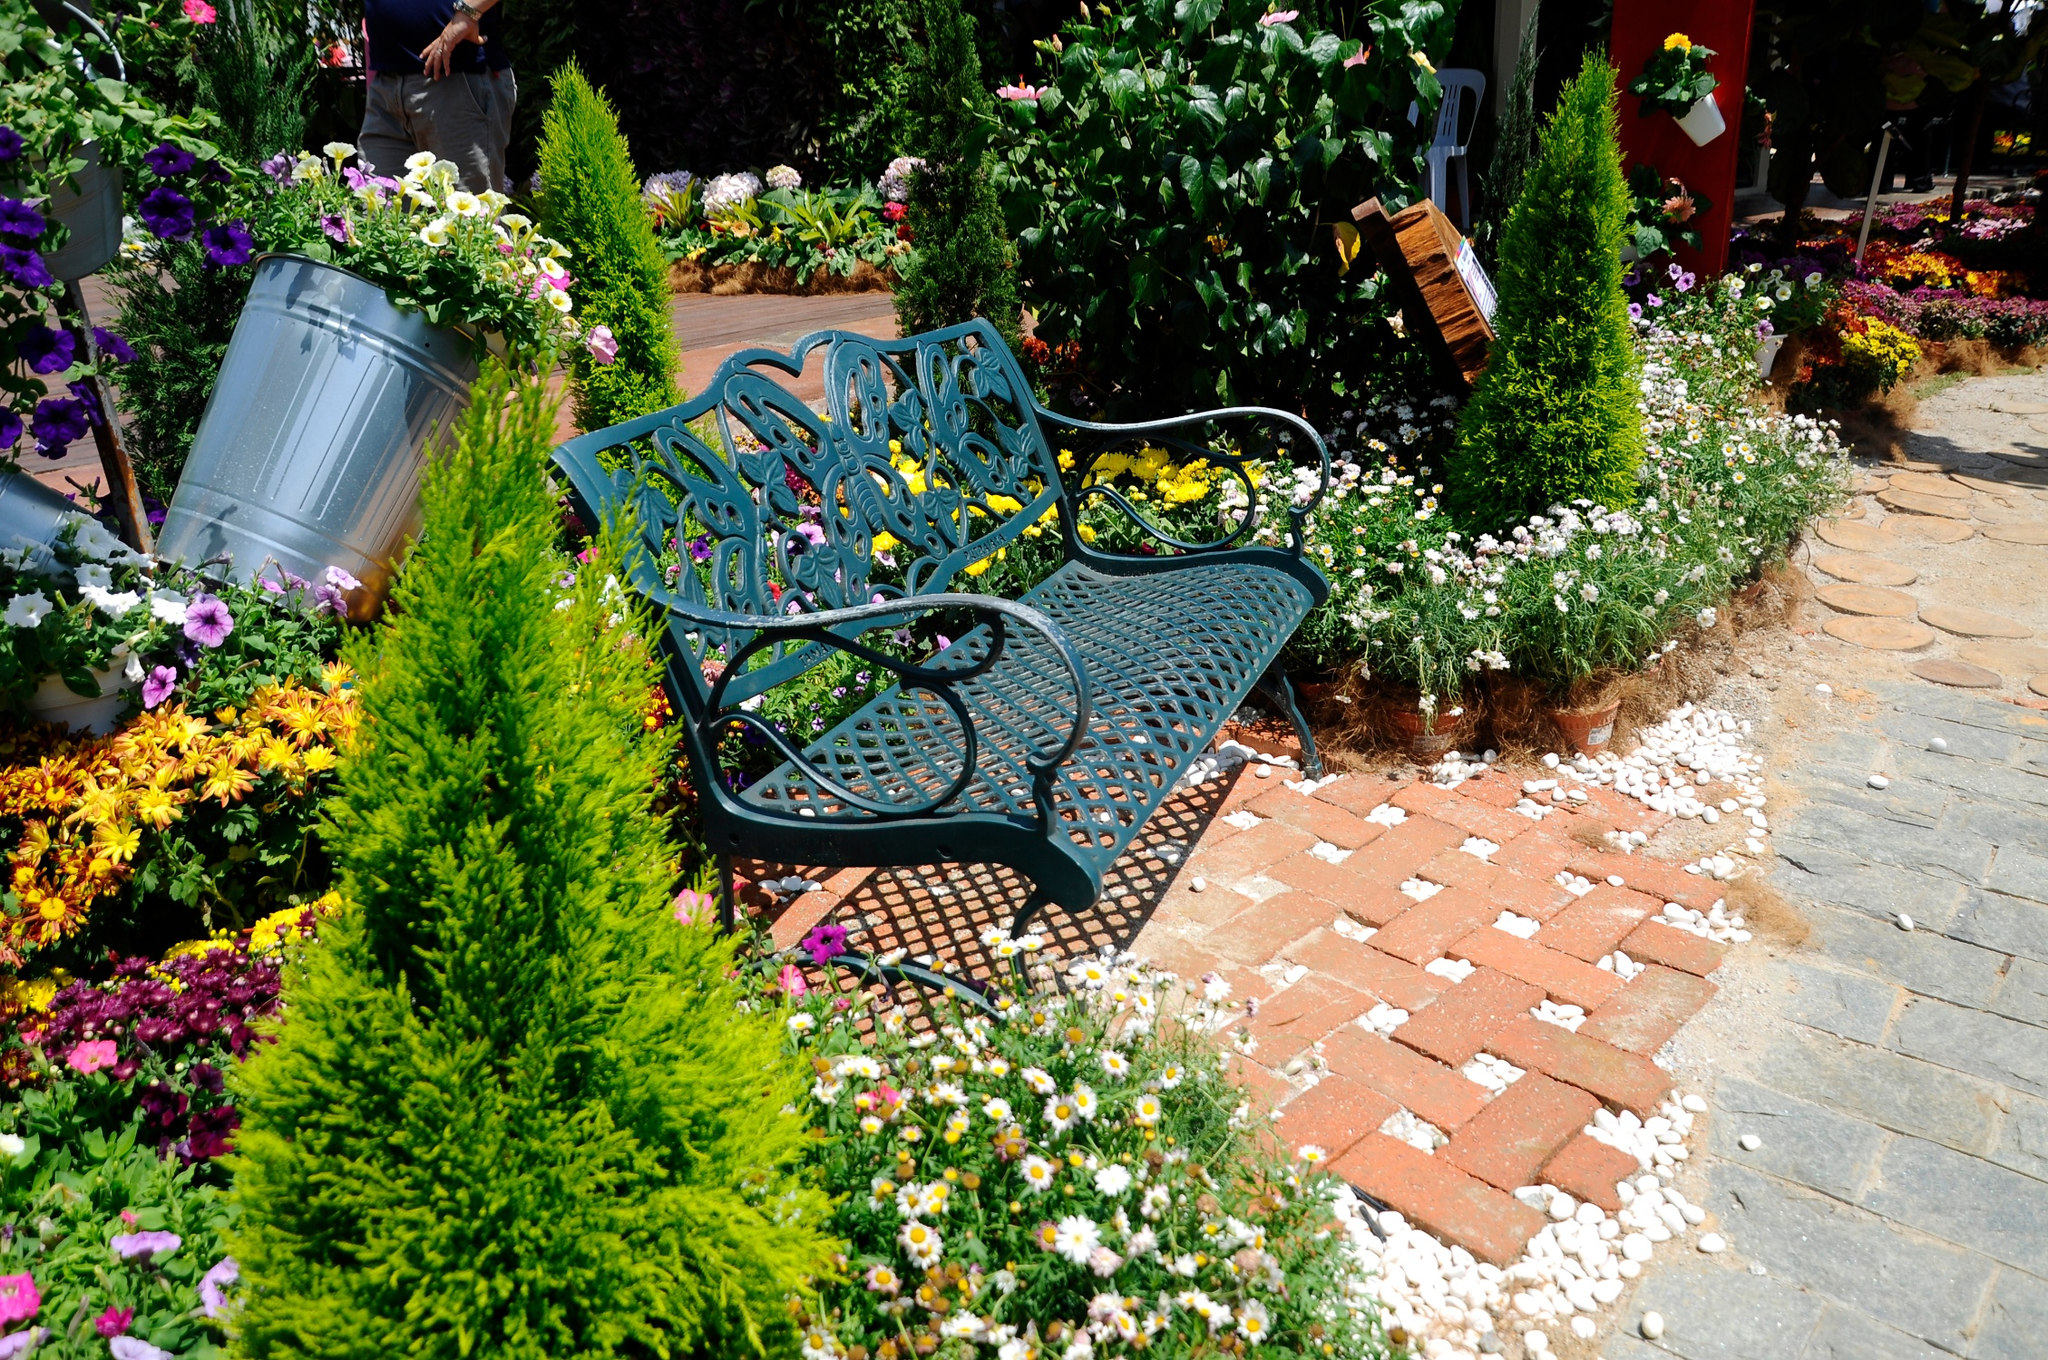What might it feel like to sit on this bench in the garden? Sitting on this beautifully designed bench would likely be a profoundly peaceful experience. The intricately crafted metal, cool to the touch, provides a sturdy and comfortable seat. Surrounded by vibrant blooms and lush greenery, you would be enveloped in the soothing scents of fresh flowers. The gentle rustling of leaves and the occasional chirping of birds would enhance the serene ambiance, making it a perfect spot for contemplation or simply appreciating the beauty of nature. Can you describe the sounds and scents one might experience in this garden? In this garden, your senses would be delighted by a symphony of nature's finest. The sounds of birds singing joyously from nearby trees would create a melodic backdrop. Insects buzzing softly and the gentle whisper of a breeze brushing through the leaves add to the natural sounds. Occasionally, you might hear the distant murmur of a nearby brook or the soft crunch of pebbles underfoot as someone walks by. The air is thick with the sweet fragrance of blooming flowers—floral notes of roses, the fresh scent of daisies, and the delicate aroma of lilies mingling in the air. Earthy undertones from the moist soil and the faint, refreshing scent of grass after watering would complete this olfactory paradise. 